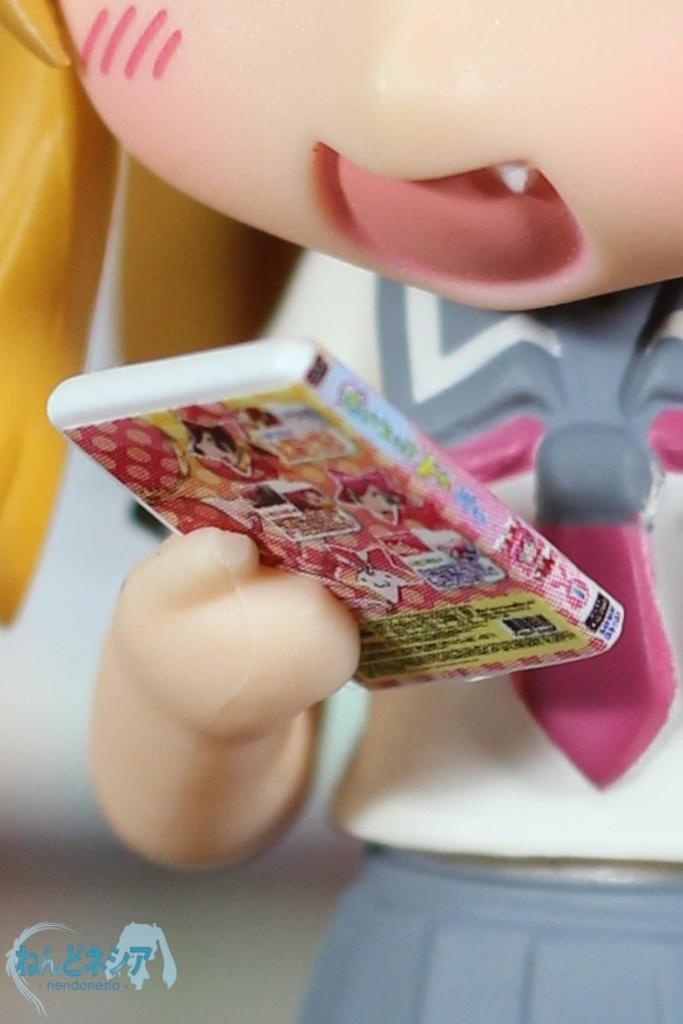Describe this image in one or two sentences. In this image there is a person toy holding a book. Left bottom there is some text. 